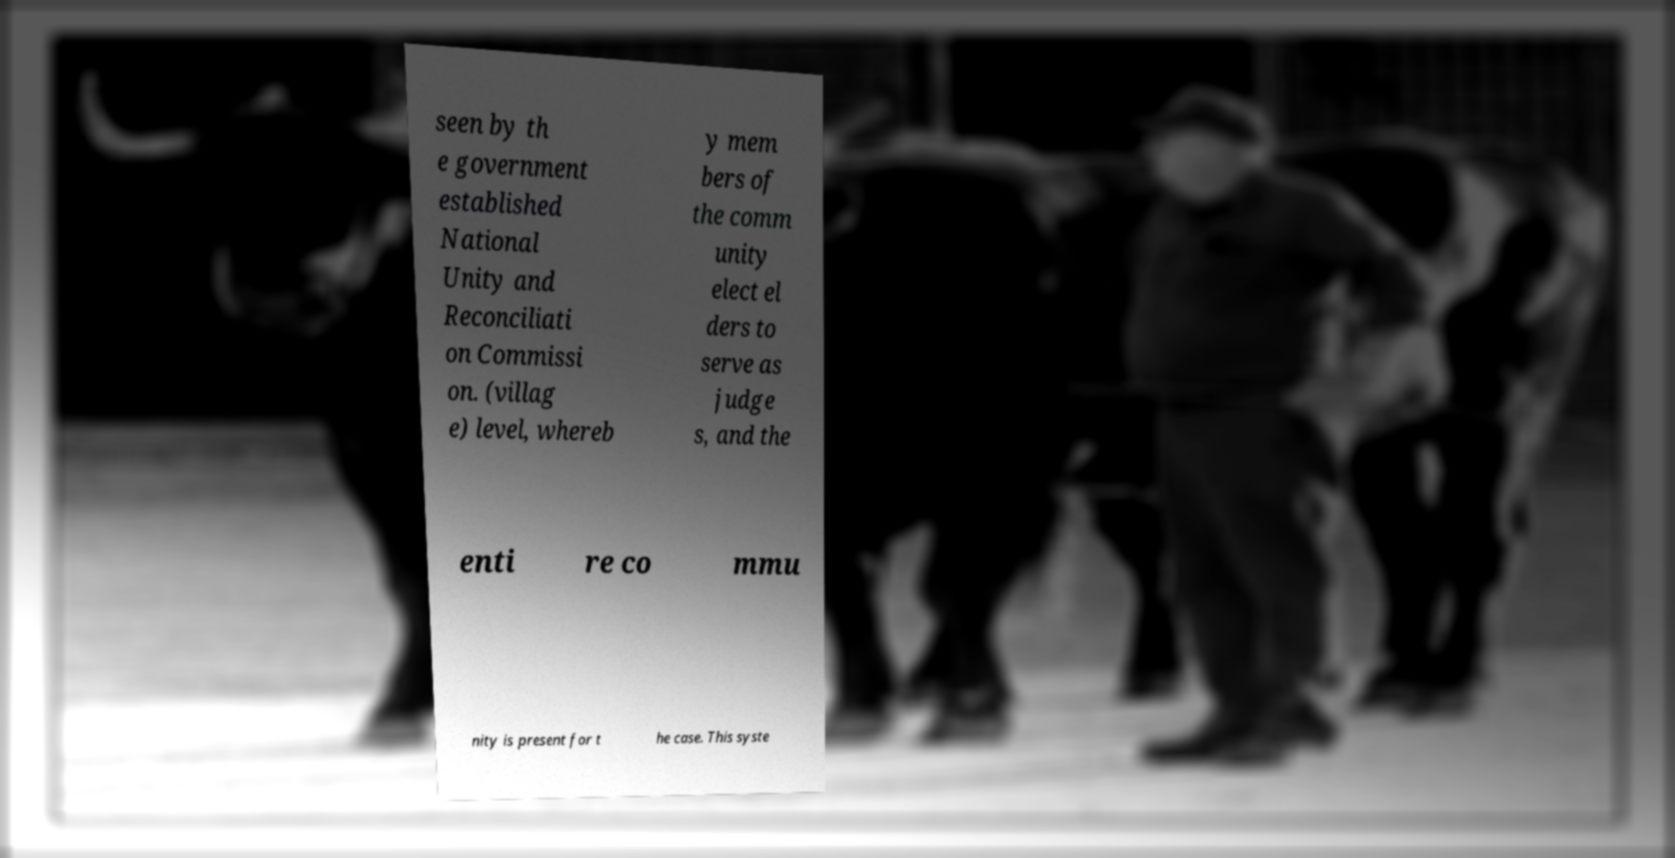Could you assist in decoding the text presented in this image and type it out clearly? seen by th e government established National Unity and Reconciliati on Commissi on. (villag e) level, whereb y mem bers of the comm unity elect el ders to serve as judge s, and the enti re co mmu nity is present for t he case. This syste 